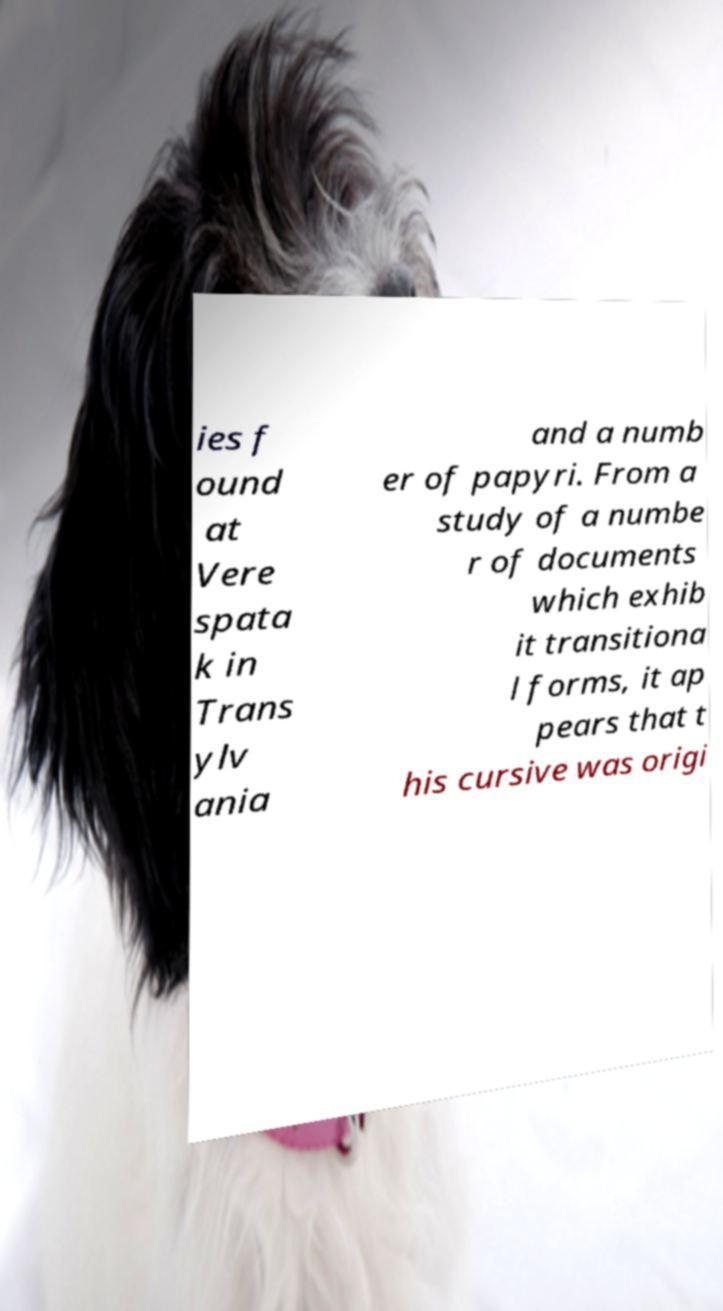For documentation purposes, I need the text within this image transcribed. Could you provide that? ies f ound at Vere spata k in Trans ylv ania and a numb er of papyri. From a study of a numbe r of documents which exhib it transitiona l forms, it ap pears that t his cursive was origi 